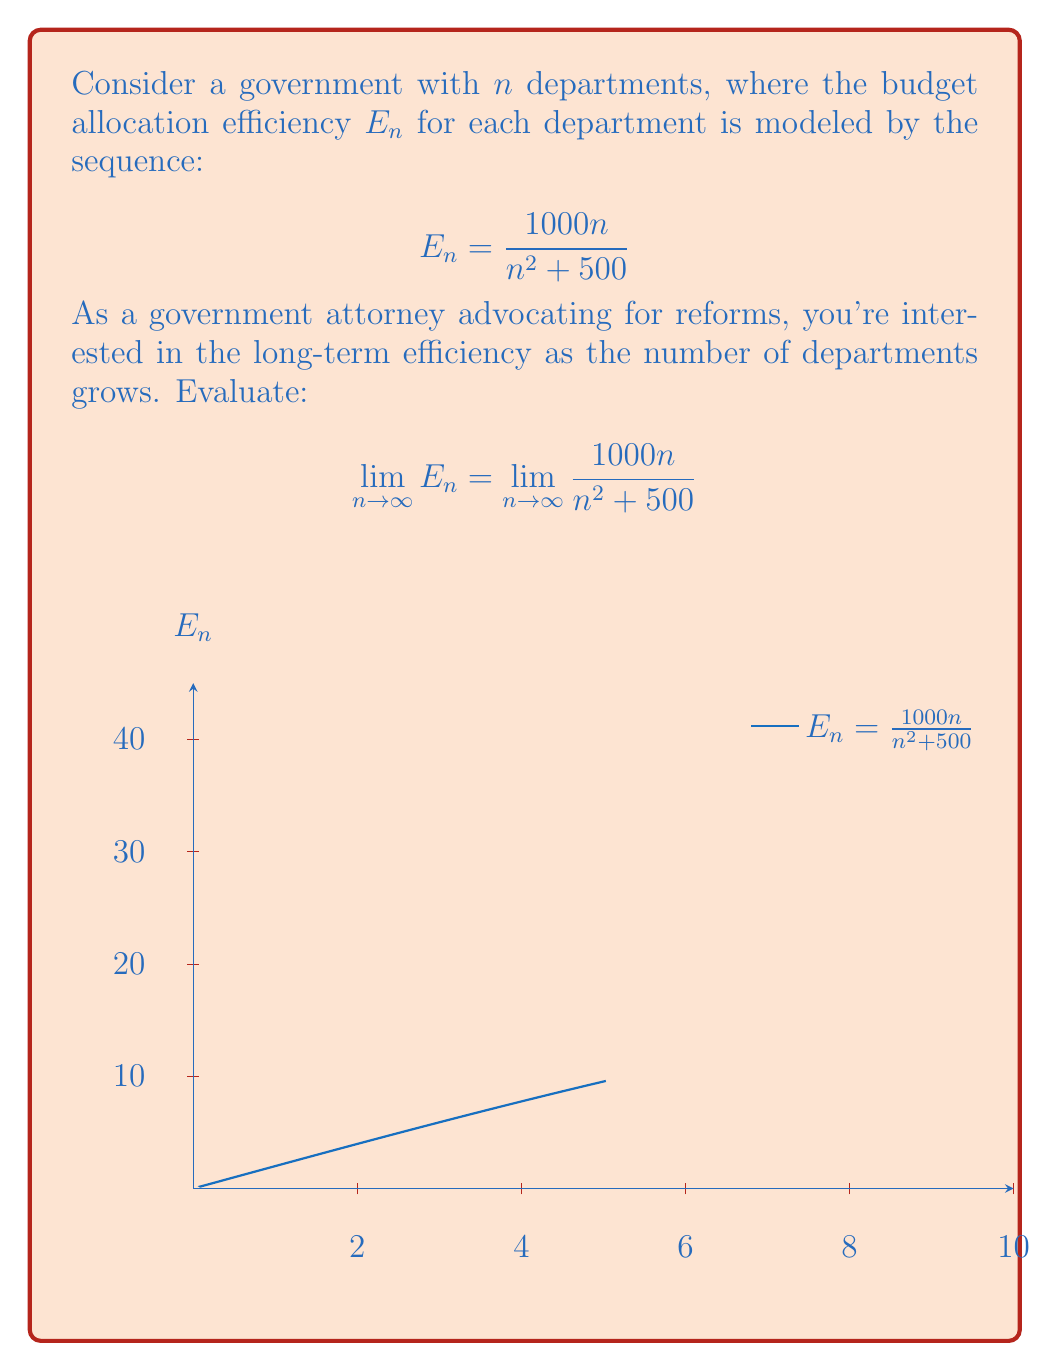What is the answer to this math problem? To evaluate this limit, we'll follow these steps:

1) First, let's consider the behavior of the numerator and denominator as $n$ approaches infinity:
   - Numerator: $1000n$ grows linearly with $n$
   - Denominator: $n^2 + 500$ is dominated by $n^2$ as $n$ gets very large

2) We can factor out $n^2$ from both numerator and denominator:

   $$\lim_{n \to \infty} \frac{1000n}{n^2 + 500} = \lim_{n \to \infty} \frac{1000 \cdot \frac{n}{n^2}}{1 + \frac{500}{n^2}}$$

3) Simplify:

   $$= \lim_{n \to \infty} \frac{1000 \cdot \frac{1}{n}}{1 + \frac{500}{n^2}}$$

4) As $n$ approaches infinity:
   - $\frac{1}{n}$ approaches 0
   - $\frac{500}{n^2}$ approaches 0 faster than $\frac{1}{n}$

5) Therefore:

   $$= \frac{1000 \cdot 0}{1 + 0} = 0$$

This result suggests that as the number of departments approaches infinity, the efficiency of budget allocation for each department approaches zero, indicating a potential need for reform in large bureaucracies.
Answer: $0$ 